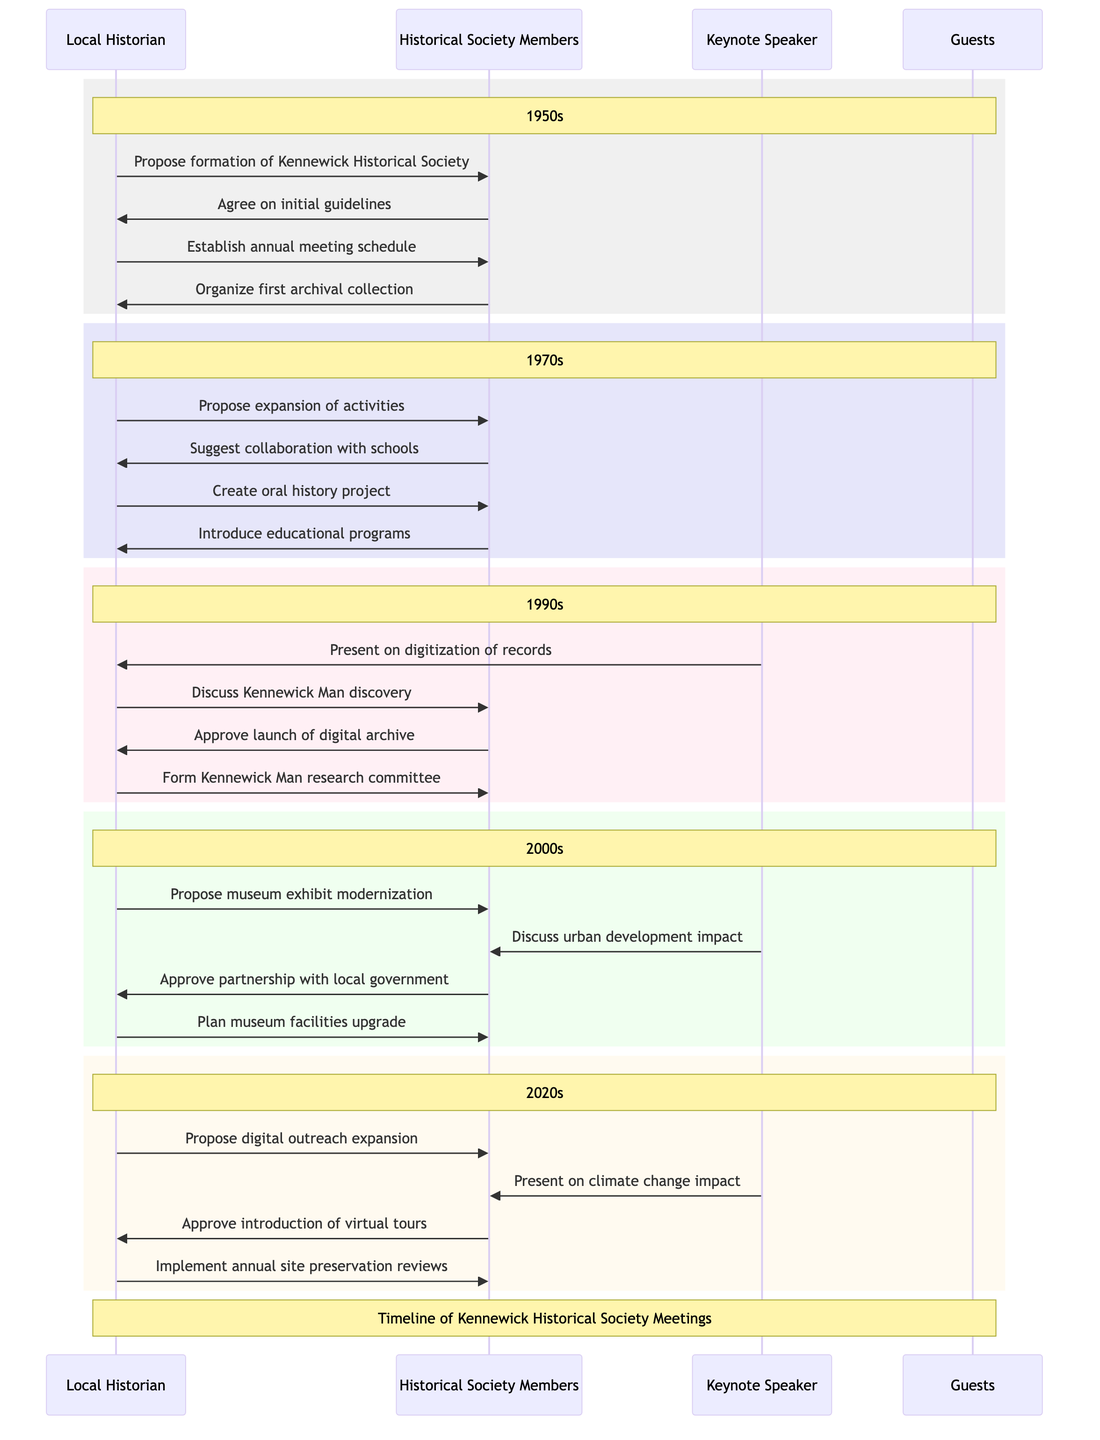What decade did the first archival collection get organized? The diagram indicates that the first archival collection was organized in the 1950s, as depicted in the section highlighting that decade.
Answer: 1950s How many resolutions are discussed in the 1970s? By reviewing the 1970s section of the diagram, we can see that there are two resolutions listed: the creation of an oral history project and the introduction of educational programs.
Answer: 2 Which member proposed the expansion of activities in the 1970s? The sequence diagram shows that the Local Historian proposed the expansion of activities to the Historical Society Members during the 1970s meetings.
Answer: Local Historian What key discussion was related to the Kennewick Man in the 1990s? The diagram illustrates that the key discussion regarding Kennewick Man in the 1990s involved the discovery and subsequent debates surrounding it, as indicated by the dialogue in that section.
Answer: Kennewick Man discovery How does the 2020s resolution on digital outreach connect to a key discussion? The diagram presents a direct link between the key discussion in the 2020s about expanding digital outreach and the resolution to introduce virtual tours, indicating a clear relationship.
Answer: Digital outreach expansion Who provided insights on climate change impact in the 2020s? The Keynote Speaker is shown in the 2020s section of the diagram as presenting insights on the impact of climate change on historic sites.
Answer: Keynote Speaker What resolved action was approved in the 2000s regarding museum facilities? The diagram states that in the 2000s, the Historical Society Members approved the plan to upgrade museum facilities as a resolution, highlighting an important action taken in that decade.
Answer: Upgradation of museum facilities Which decade saw the launch of a digital archive? The launch of a digital archive is mentioned in the resolutions for the 1990s, suggesting that this was the decade when this initiative was introduced.
Answer: 1990s How many key discussions are there in total across all decades? By counting the key discussions outlined in each decade of the diagram—2 in the 1950s, 2 in the 1970s, 2 in the 1990s, 2 in the 2000s, and 2 in the 2020s—there are a total of 10 key discussions across all decades.
Answer: 10 